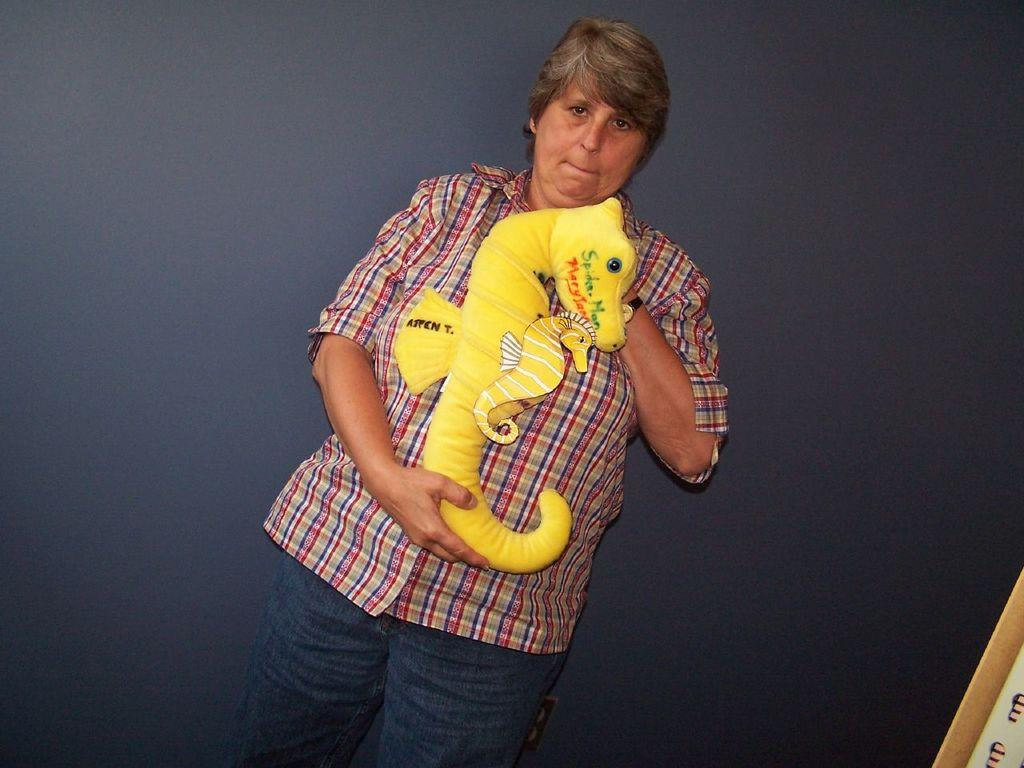Who or what is present in the image? There is a person in the image. What is the person doing in the image? The person is looking forward. What object is the person holding in the image? The person is holding a toy. What can be seen in the background of the image? There is a wall in the background of the image. What type of pig can be seen in the image? There is no pig present in the image. How does the person's brain appear in the image? The person's brain is not visible in the image. 